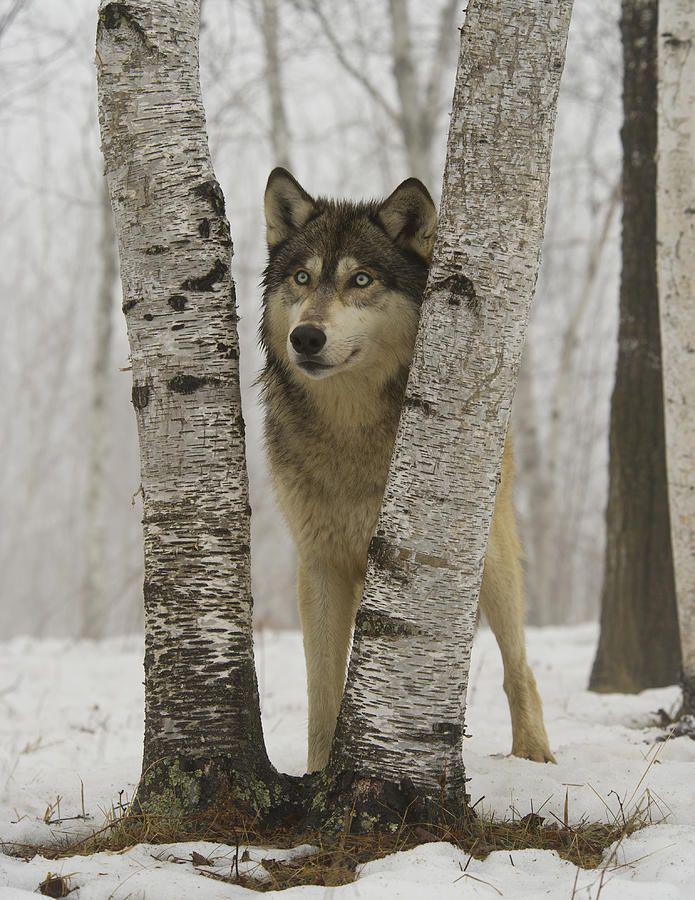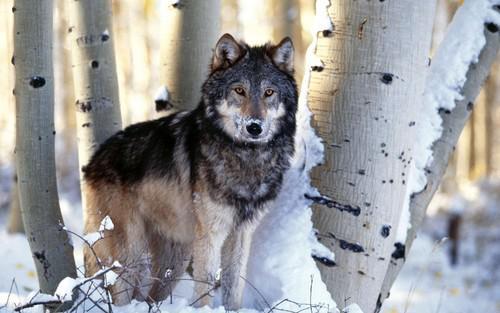The first image is the image on the left, the second image is the image on the right. Considering the images on both sides, is "Each image contains exactly one wolf, and all wolves shown are upright instead of reclining." valid? Answer yes or no. Yes. The first image is the image on the left, the second image is the image on the right. Given the left and right images, does the statement "At least one wolf is sitting." hold true? Answer yes or no. No. 